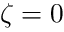<formula> <loc_0><loc_0><loc_500><loc_500>\zeta = 0</formula> 